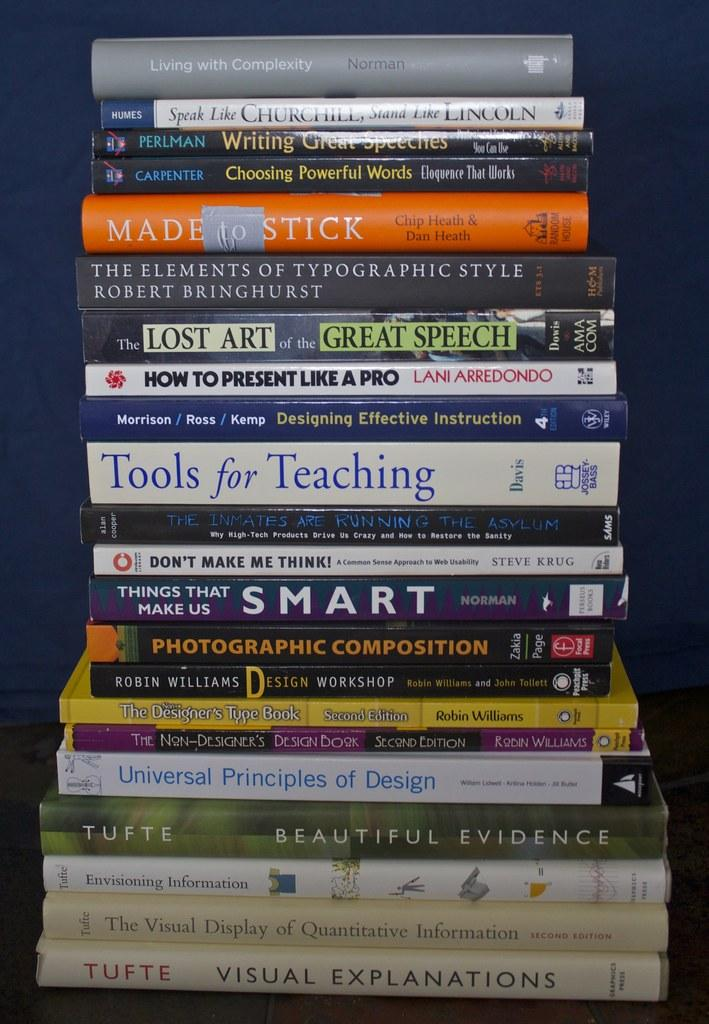Provide a one-sentence caption for the provided image. A large stack of books with the top one being titled Living with Complexity. 